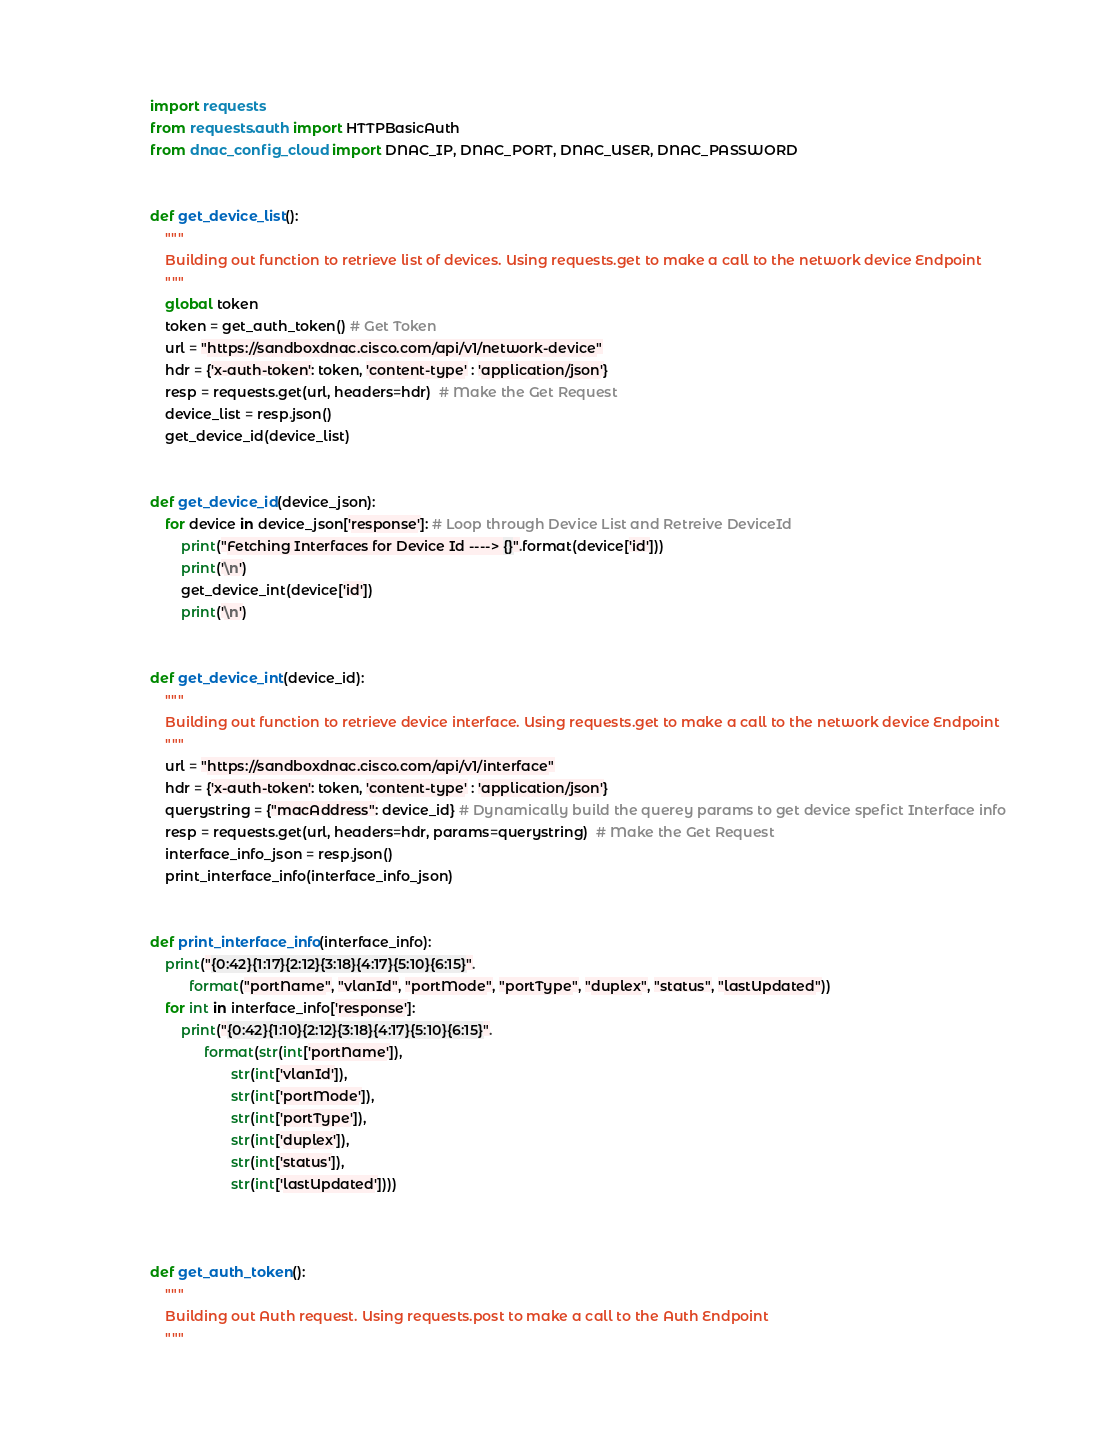Convert code to text. <code><loc_0><loc_0><loc_500><loc_500><_Python_>import requests
from requests.auth import HTTPBasicAuth
from dnac_config_cloud import DNAC_IP, DNAC_PORT, DNAC_USER, DNAC_PASSWORD


def get_device_list():
    """
    Building out function to retrieve list of devices. Using requests.get to make a call to the network device Endpoint
    """
    global token
    token = get_auth_token() # Get Token
    url = "https://sandboxdnac.cisco.com/api/v1/network-device"
    hdr = {'x-auth-token': token, 'content-type' : 'application/json'}
    resp = requests.get(url, headers=hdr)  # Make the Get Request
    device_list = resp.json()
    get_device_id(device_list)


def get_device_id(device_json):
    for device in device_json['response']: # Loop through Device List and Retreive DeviceId
        print("Fetching Interfaces for Device Id ----> {}".format(device['id']))
        print('\n')
        get_device_int(device['id'])
        print('\n')


def get_device_int(device_id):
    """
    Building out function to retrieve device interface. Using requests.get to make a call to the network device Endpoint
    """
    url = "https://sandboxdnac.cisco.com/api/v1/interface"
    hdr = {'x-auth-token': token, 'content-type' : 'application/json'}
    querystring = {"macAddress": device_id} # Dynamically build the querey params to get device spefict Interface info
    resp = requests.get(url, headers=hdr, params=querystring)  # Make the Get Request
    interface_info_json = resp.json()
    print_interface_info(interface_info_json)


def print_interface_info(interface_info):
    print("{0:42}{1:17}{2:12}{3:18}{4:17}{5:10}{6:15}".
          format("portName", "vlanId", "portMode", "portType", "duplex", "status", "lastUpdated"))
    for int in interface_info['response']:
        print("{0:42}{1:10}{2:12}{3:18}{4:17}{5:10}{6:15}".
              format(str(int['portName']),
                     str(int['vlanId']),
                     str(int['portMode']),
                     str(int['portType']),
                     str(int['duplex']),
                     str(int['status']),
                     str(int['lastUpdated'])))



def get_auth_token():
    """
    Building out Auth request. Using requests.post to make a call to the Auth Endpoint
    """</code> 